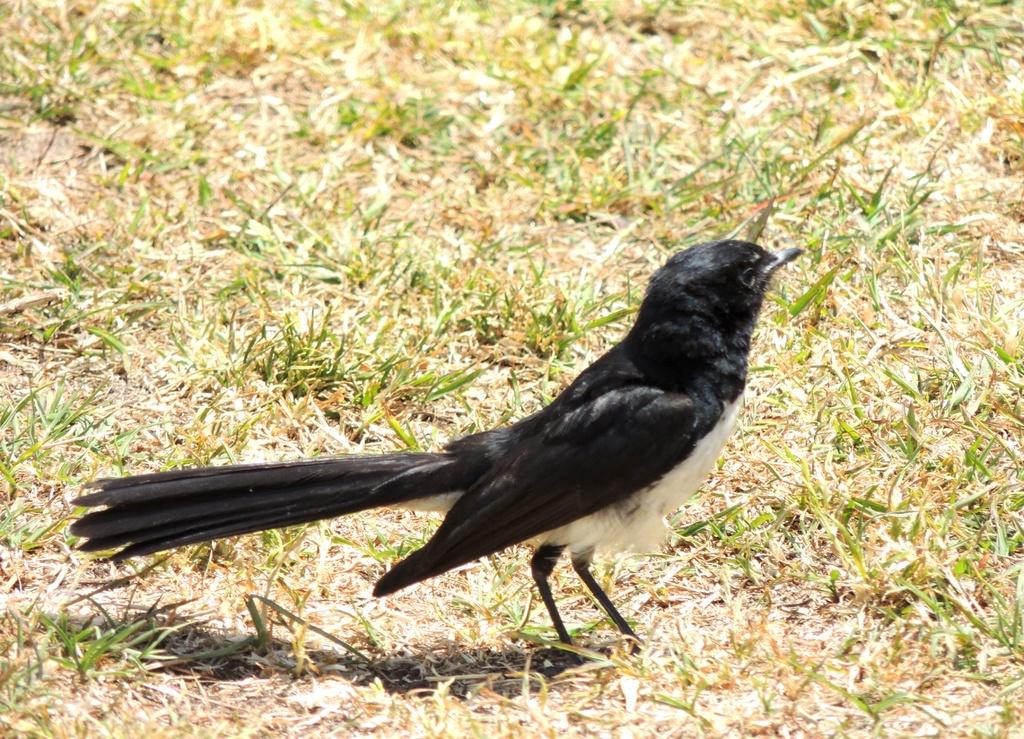What type of bird can be seen in the image? There is a black color bird in the image. Where is the bird located? The bird is standing on the grassland. What type of pump can be seen in the image? There is no pump present in the image; it features a black color bird standing on the grassland. What type of rice is being harvested by the laborer in the image? There is no laborer or rice harvesting depicted in the image; it only shows a black color bird standing on the grassland. 